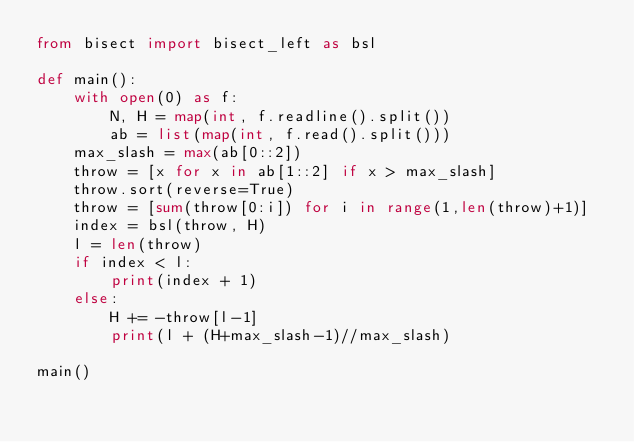<code> <loc_0><loc_0><loc_500><loc_500><_Python_>from bisect import bisect_left as bsl

def main():
    with open(0) as f:
        N, H = map(int, f.readline().split())
        ab = list(map(int, f.read().split()))
    max_slash = max(ab[0::2])
    throw = [x for x in ab[1::2] if x > max_slash]
    throw.sort(reverse=True)
    throw = [sum(throw[0:i]) for i in range(1,len(throw)+1)]
    index = bsl(throw, H)
    l = len(throw)
    if index < l:
        print(index + 1)
    else:
        H += -throw[l-1]
        print(l + (H+max_slash-1)//max_slash)

main()

    </code> 